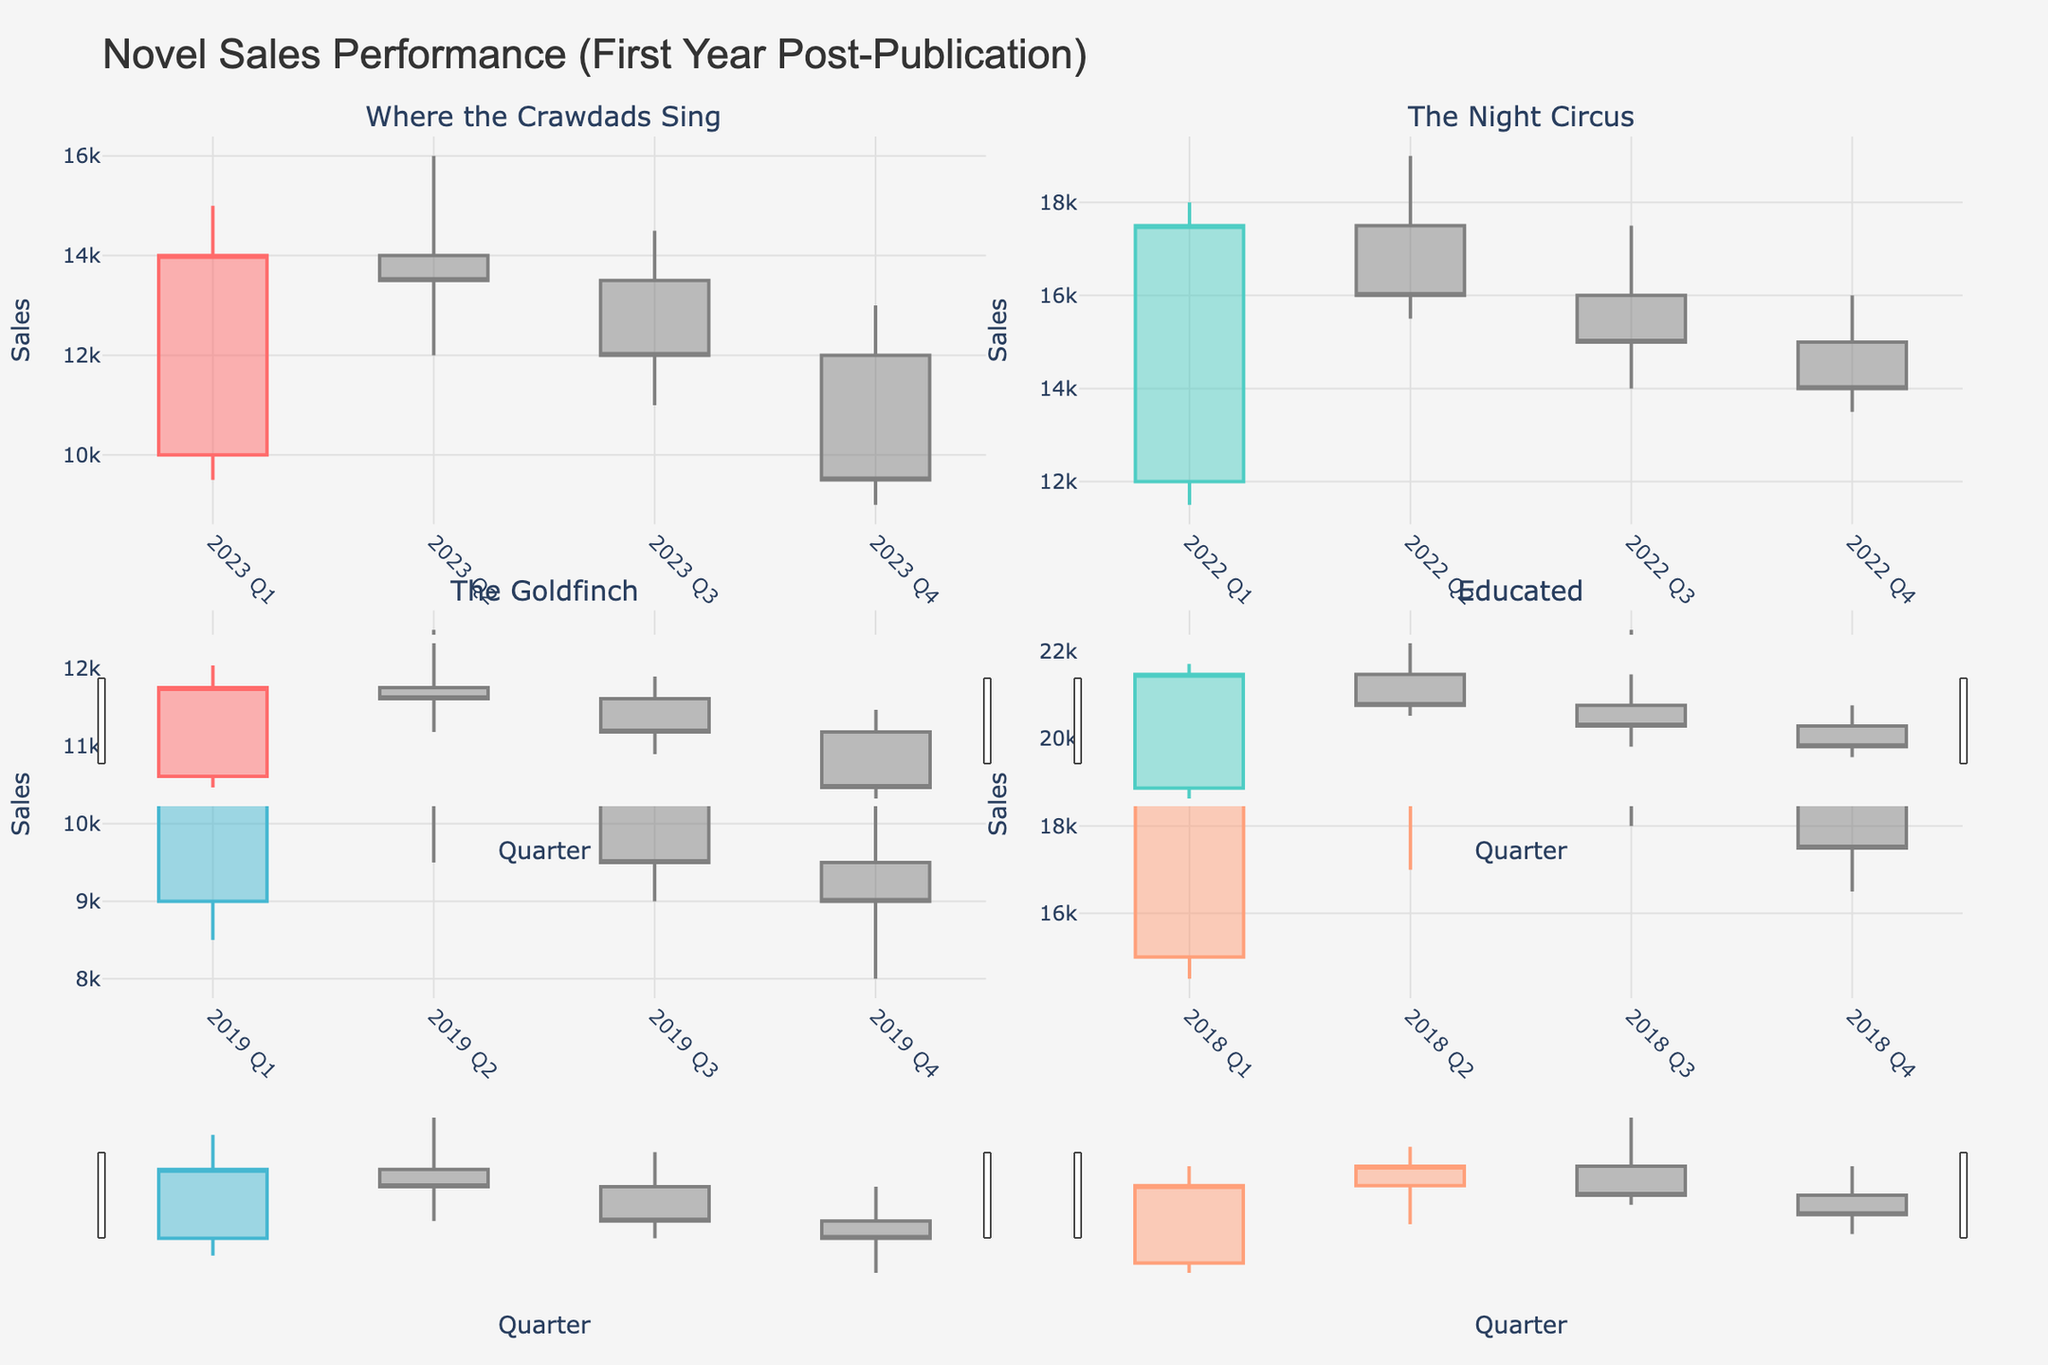What is the title of the plot? The title of the plot is written at the top and clearly states the overall theme of the figure.
Answer: Novel Sales Performance (First Year Post-Publication) What quarters are covered for the novel "Where the Crawdads Sing"? By looking at the x-axis for the subplot corresponding to "Where the Crawdads Sing", we can see all the quarters listed.
Answer: Q1, Q2, Q3, Q4 What is the highest sales value recorded in "The Night Circus" subplot? The highest sales value is represented by the uppermost point of the 'High' line in the candlestick plot. In "The Night Circus" subplot, this value is marked along the vertical axis.
Answer: 19000 Between "Educated" in Q1 and Q4, which quarter had higher sales at the close? By comparing where the closing values (the right line of the candlestick body) fall in the subplot, we see the values of Q1 and Q4. Q1 has a close value of 19000, and Q4 has a close value of 17500.
Answer: Q1 What is the average closing sales value for "The Goldfinch"? To find the average, add the closing values for all quarters and divide by the number of quarters: (11000 + 10500 + 9500 + 9000)/4 = 40000/4 = 10000
Answer: 10000 Which novel showed the steepest decline in sales from Q1 to Q4? For each novel, compare the opening value in Q1 to the closing value in Q4 and find the one with the largest difference. "Where the Crawdads Sing" dropped from 10000 to 9500, "The Night Circus" from 12000 to 14000, "The Goldfinch" from 9000 to 9000, and "Educated" from 15000 to 17500. "Where the Crawdads Sing" shows the largest drop.
Answer: Where the Crawdads Sing In which quarter of "Educated" did the highest sales take place? Examining the candlestick plot for "Educated", we find the highest point on the figure, which represents the highest sales value. It's in Q3 with a high value of 22500.
Answer: Q3 Compare the sales trends of "The Night Circus" and "The Goldfinch": which has more volatile sales performance? Volatility can be measured by the range and fluctuation between the highest and lowest values across quarters. "The Night Circus" shows larger differences between highs and lows and more fluctuations compared to "The Goldfinch", which shows relatively stable numbers.
Answer: The Night Circus 